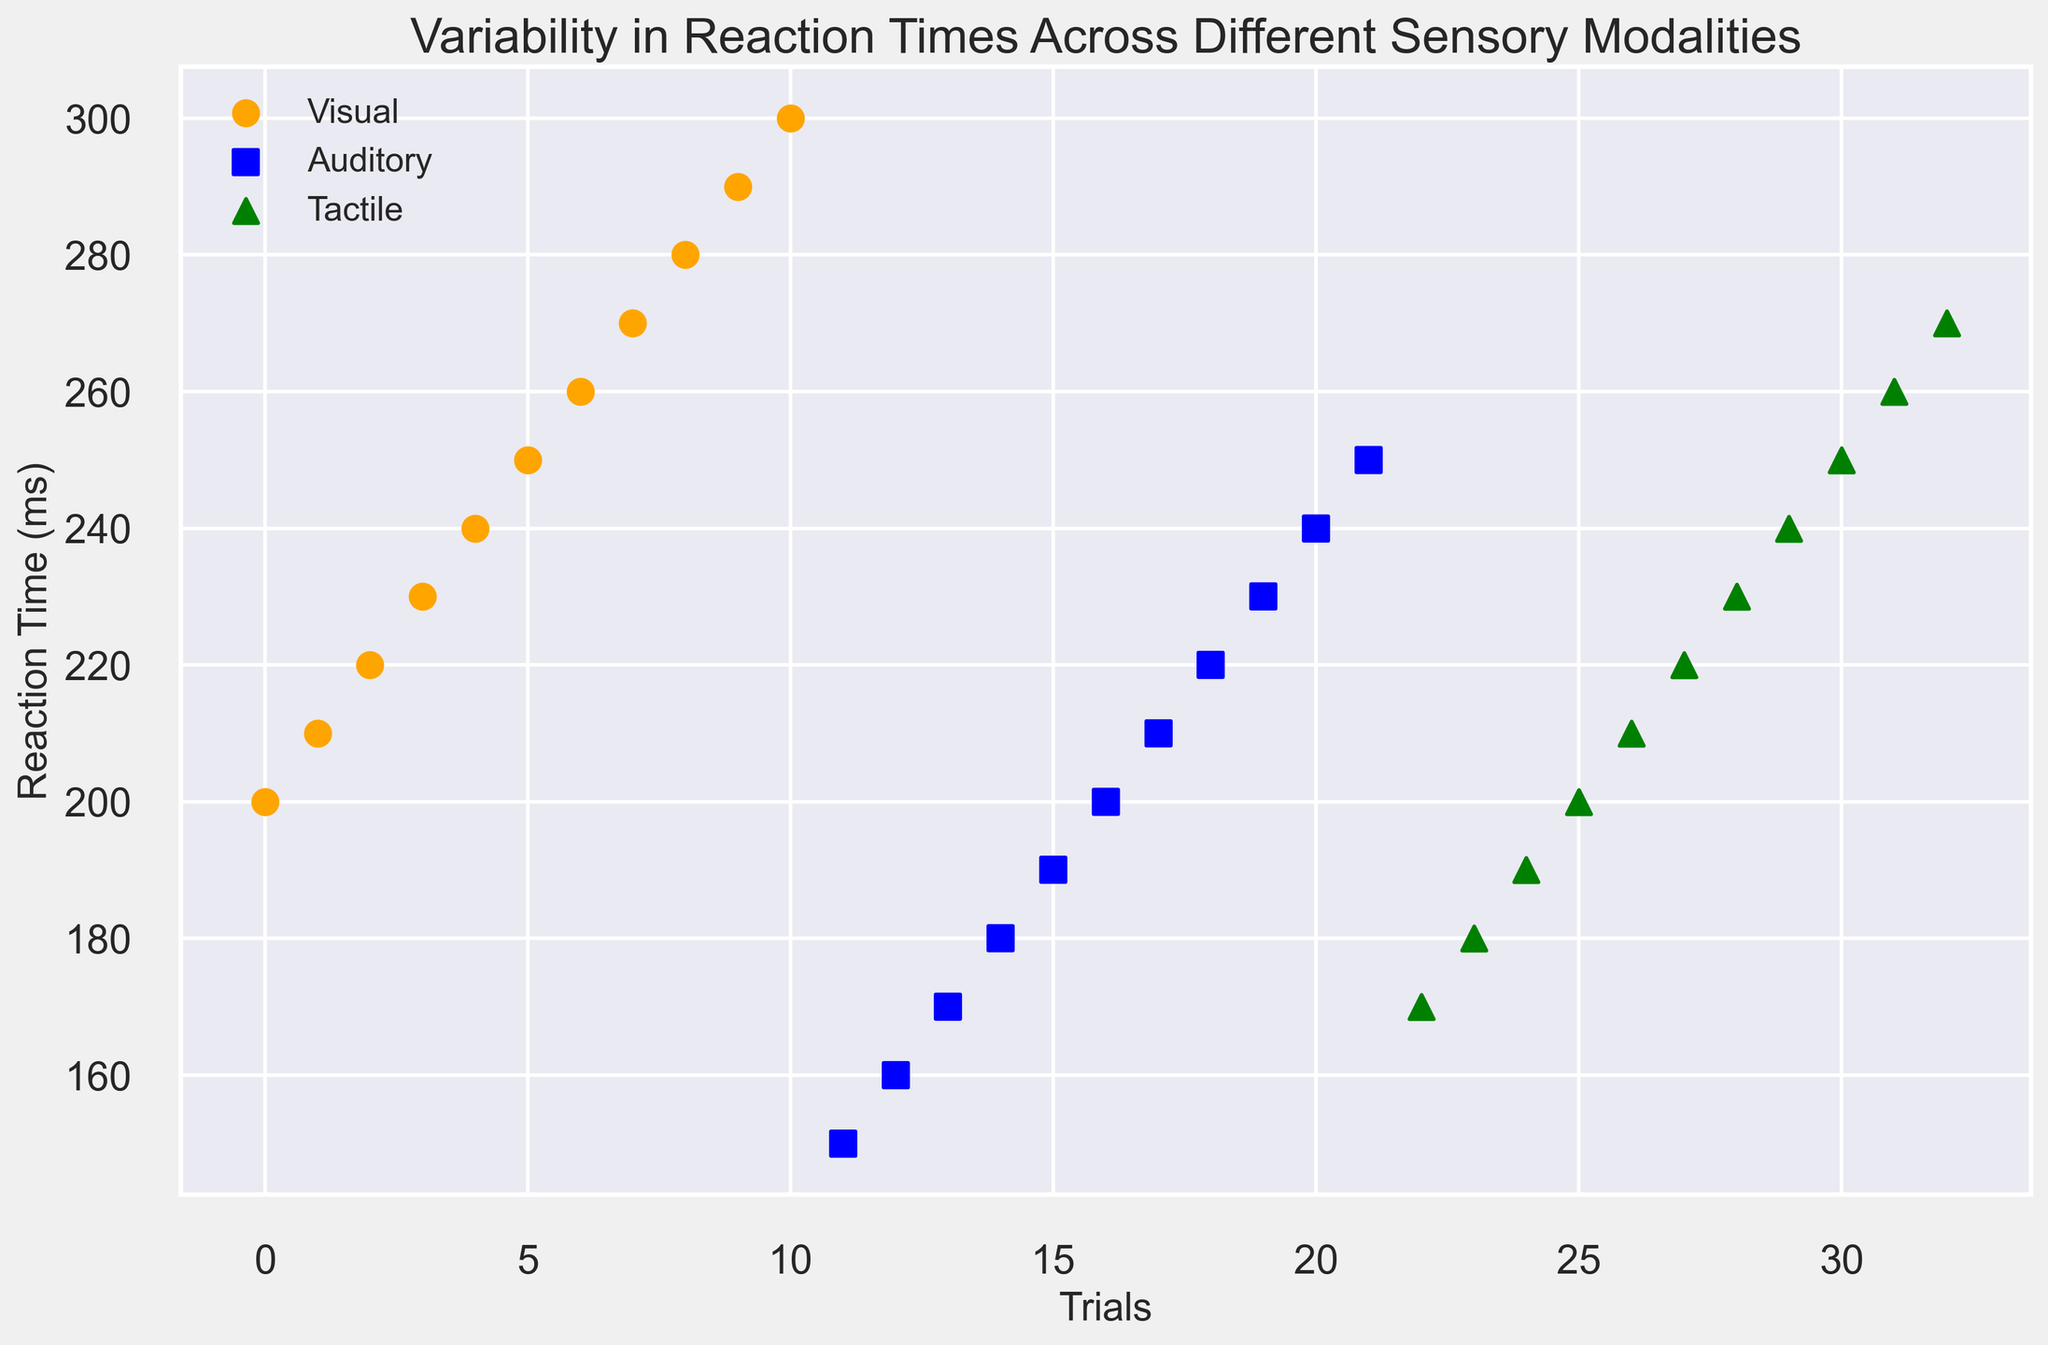What is the average reaction time for the visual modality? To find the average, sum all the reaction times for the visual modality (200 + 210 + 220 + 230 + 240 + 250 + 260 + 270 + 280 + 290 + 300 = 2750) and divide by the number of trials (11). Hence, the average is 2750 / 11 ≈ 250
Answer: 250 Which sensory modality has the smallest variability in reaction times? To determine the variability, visually inspect the spread of the dots for each modality. The auditory modality shows less spread in reaction times compared to the visual and tactile modalities, indicating smaller variability
Answer: Auditory What is the difference between the highest reaction time in the visual modality and the tactile modality? The highest reaction time in the visual modality is 300 ms, and in the tactile modality, it is 270 ms. The difference is 300 - 270 = 30 ms
Answer: 30 ms How many trials have reaction times greater than 230 ms across all modalities? Count the dots above 230 ms in each modality. For visual, there are 7 trials (240, 250, 260, 270, 280, 290, 300), for auditory, there are 2 trials (240, 250), and for tactile, there are 5 trials (240, 250, 260, 270). Summing them gives 7 + 2 + 5 = 14 trials
Answer: 14 Which sensory modality has the quickest average reaction time? Calculate the average reaction time for each modality:
- Visual: 250 ms (as calculated in an earlier question)
- Auditory: (150 + 160 + 170 + 180 + 190 + 200 + 210 + 220 + 230 + 240 + 250) / 11 = 220
- Tactile: (170 + 180 + 190 + 200 + 210 + 220 + 230 + 240 + 250 + 260 + 270) / 11 ≈ 220
The auditory and tactile modalities have the same average reaction time of 220 ms, which is quicker than the visual modality
Answer: Auditory and Tactile How many trials are conducted in each modality? Count the number of data points (scattered dots) for each modality:
- Visual has 11 data points
- Auditory has 11 data points
- Tactile has 11 data points
Answer: 11 How many more trials in the auditory modality have reaction times under 200 ms compared to the tactile modality? Count the trials under 200 ms:
- Auditory: 5 trials (150, 160, 170, 180, 190)
- Tactile: 3 trials (170, 180, 190)
Difference is 5 - 3 = 2
Answer: 2 What is the range of reaction times for the visual modality? The range is calculated as the difference between the maximum and minimum reaction times. For the visual modality, the max is 300 ms and the min is 200 ms. Therefore, the range is 300 - 200 = 100 ms
Answer: 100 ms What sensory modality has the highest maximum reaction time and what is this value? Visually identify the highest point in each modality. The visual modality has the highest maximum reaction time of 300 ms
Answer: Visual, 300 ms 